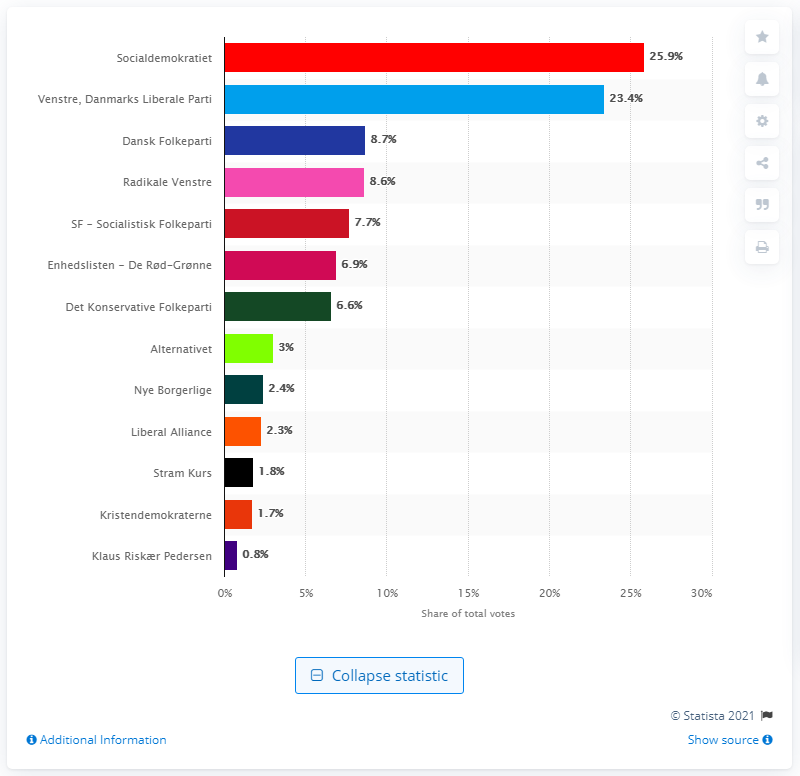Outline some significant characteristics in this image. According to the voter results, the Social Democrats received the largest proportion of votes. Radikale Venstre received the third largest share of votes in the most recent election. 